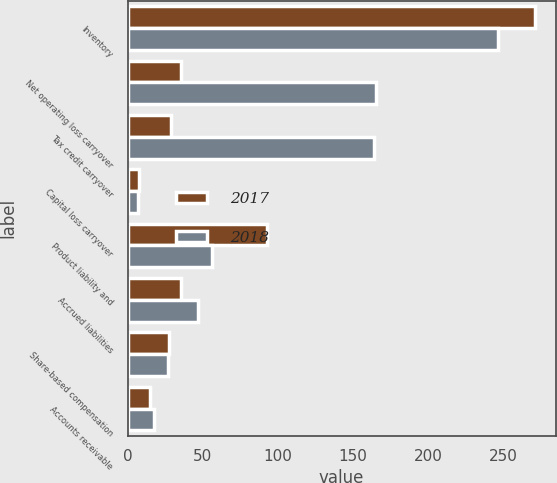Convert chart. <chart><loc_0><loc_0><loc_500><loc_500><stacked_bar_chart><ecel><fcel>Inventory<fcel>Net operating loss carryover<fcel>Tax credit carryover<fcel>Capital loss carryover<fcel>Product liability and<fcel>Accrued liabilities<fcel>Share-based compensation<fcel>Accounts receivable<nl><fcel>2017<fcel>271.5<fcel>35.3<fcel>29.2<fcel>7.9<fcel>92.6<fcel>35.3<fcel>27.3<fcel>15.2<nl><fcel>2018<fcel>246.8<fcel>165.1<fcel>163.8<fcel>6.9<fcel>55.9<fcel>46.6<fcel>26.8<fcel>17.3<nl></chart> 